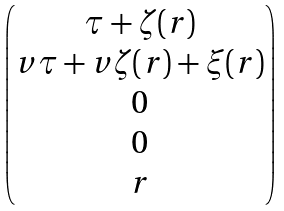<formula> <loc_0><loc_0><loc_500><loc_500>\begin{pmatrix} \tau + \zeta ( r ) \\ v \tau + v \zeta ( r ) + \xi ( r ) \\ 0 \\ 0 \\ r \end{pmatrix}</formula> 